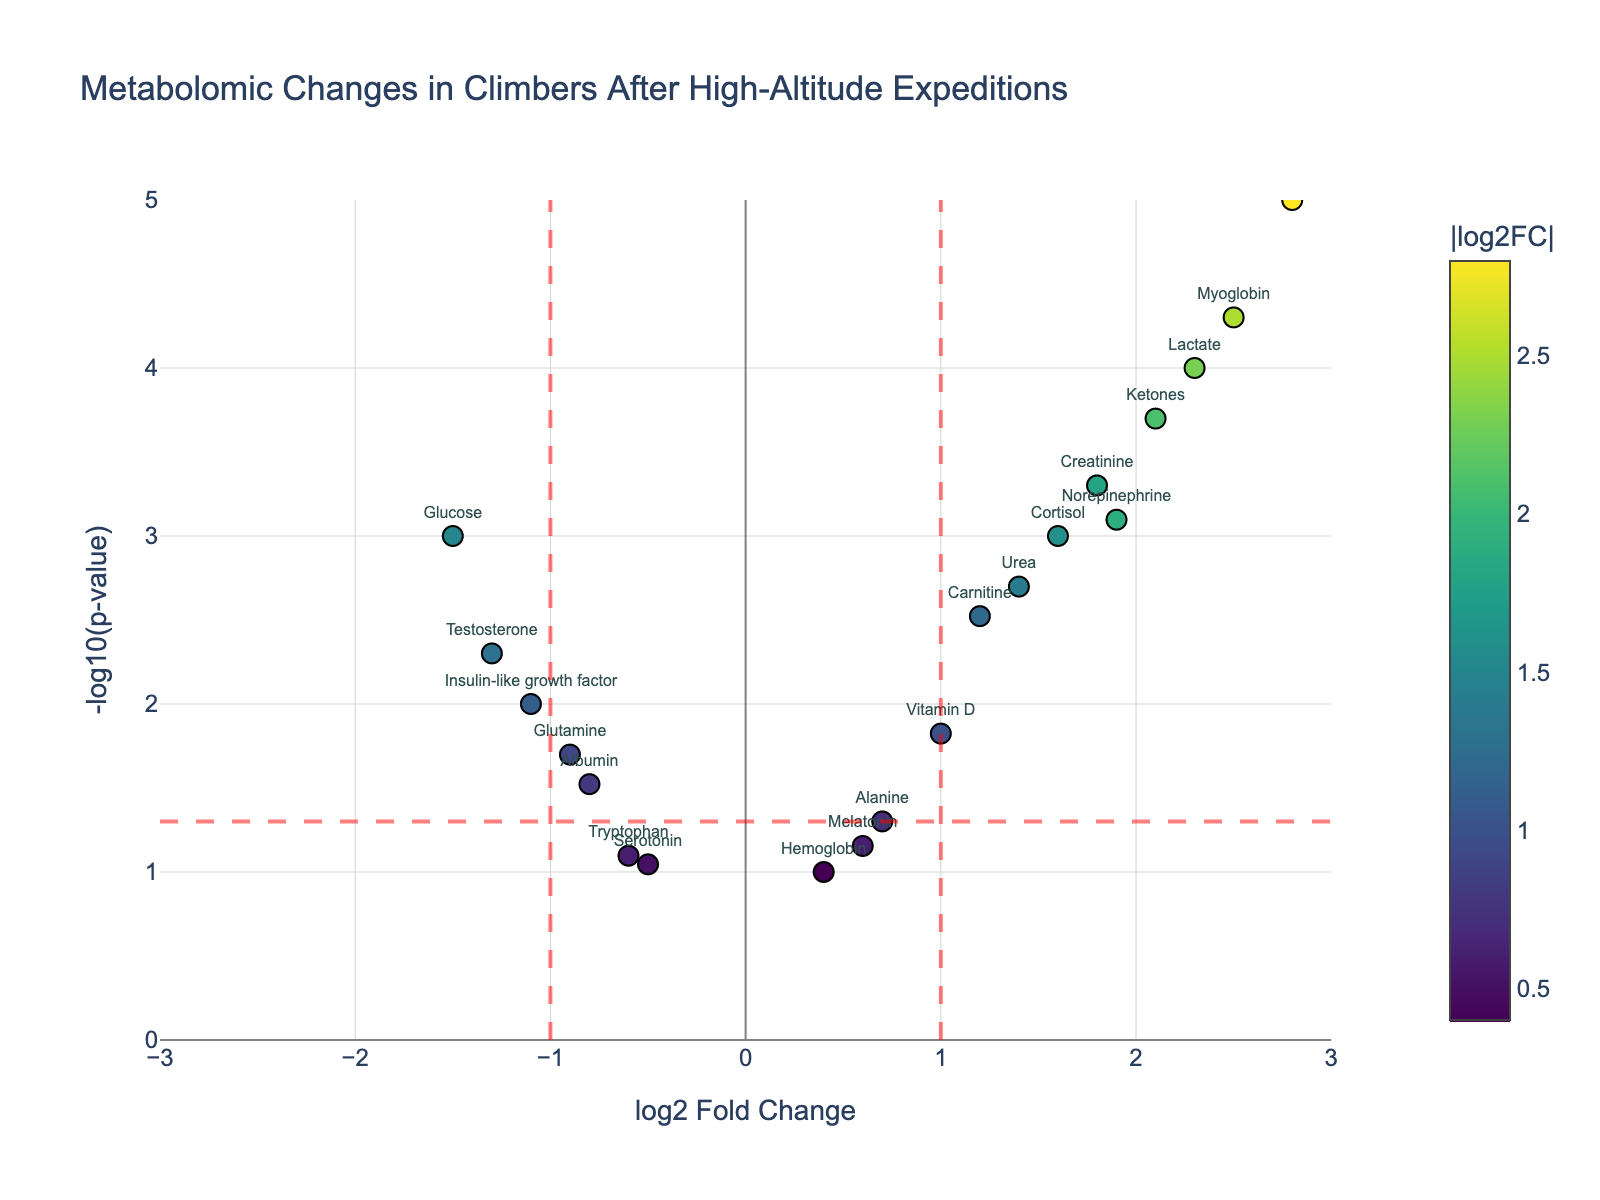Which metabolite has the highest -log10(p-value)? Looking at the y-axis (which represents -log10(p-value)), the data point with the highest -log10(p-value) is Erythropoietin.
Answer: Erythropoietin How many metabolites show a significant log2 fold change greater than 1? A log2 fold change greater than 1 would be all data points to the right of the vertical line at x=1. There are six such metabolites: Lactate, Creatinine, Ketones, Cortisol, Urea, and Norepinephrine.
Answer: 6 Which metabolite is significantly downregulated (log2 fold change < -1 with significant p-value)? A significantly downregulated metabolite would be to the left of the vertical line at x=-1 and above the horizontal line for p-value < 0.05. Testosterone fits this criterion.
Answer: Testosterone Which metabolites have a p-value greater than 0.05? Data points that fall below the horizontal red line at -log10(0.05) (around y=1.3) have p-values greater than 0.05. These metabolites are Tryptophan, Hemoglobin, Serotonin, and Melatonin.
Answer: Tryptophan, Hemoglobin, Serotonin, Melatonin What is the range of -log10(p-value) shown on the plot? The y-axis range is from 0 to 5, as indicated by the axis limits.
Answer: 0 to 5 Which metabolite has the largest positive log2 fold change? By looking at the x-axis (which represents log2 fold change), the metabolite with the largest positive value is Erythropoietin.
Answer: Erythropoietin Compare Lactate and Glucose in terms of their log2 fold changes. Which one is upregulated and which one is downregulated? Lactate has a positive log2 fold change (2.3), meaning it is upregulated. Glucose has a negative log2 fold change (-1.5), meaning it is downregulated.
Answer: Lactate is upregulated, Glucose is downregulated Is there any metabolite close to the significance cutoff but not significant? Alanine is close to the significance cutoff with a p-value close to 0.05 but not significant as it is right below the threshold y=1.3 (-log10(0.05)).
Answer: Alanine How many metabolites are both significantly upregulated and have a log2 fold change greater than 2? From the plot elements above both the x=2 and y=1.3 thresholds, there are three such metabolites: Lactate, Myoglobin, and Erythropoietin.
Answer: 3 